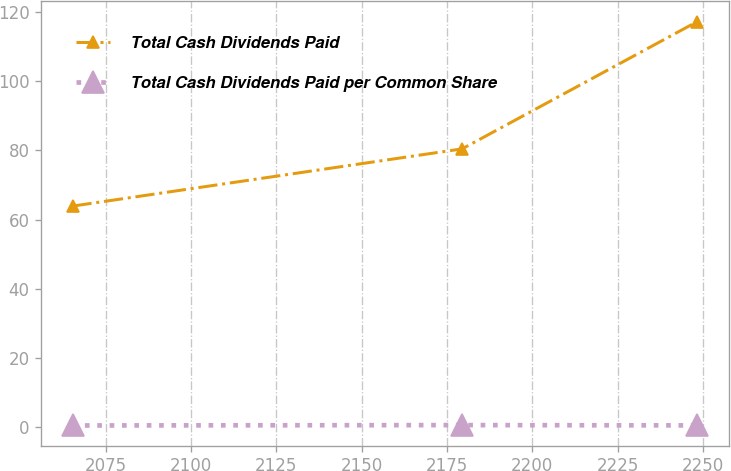<chart> <loc_0><loc_0><loc_500><loc_500><line_chart><ecel><fcel>Total Cash Dividends Paid<fcel>Total Cash Dividends Paid per Common Share<nl><fcel>2065.25<fcel>63.87<fcel>0.51<nl><fcel>2179.43<fcel>80.4<fcel>0.62<nl><fcel>2248.41<fcel>117.19<fcel>0.53<nl></chart> 